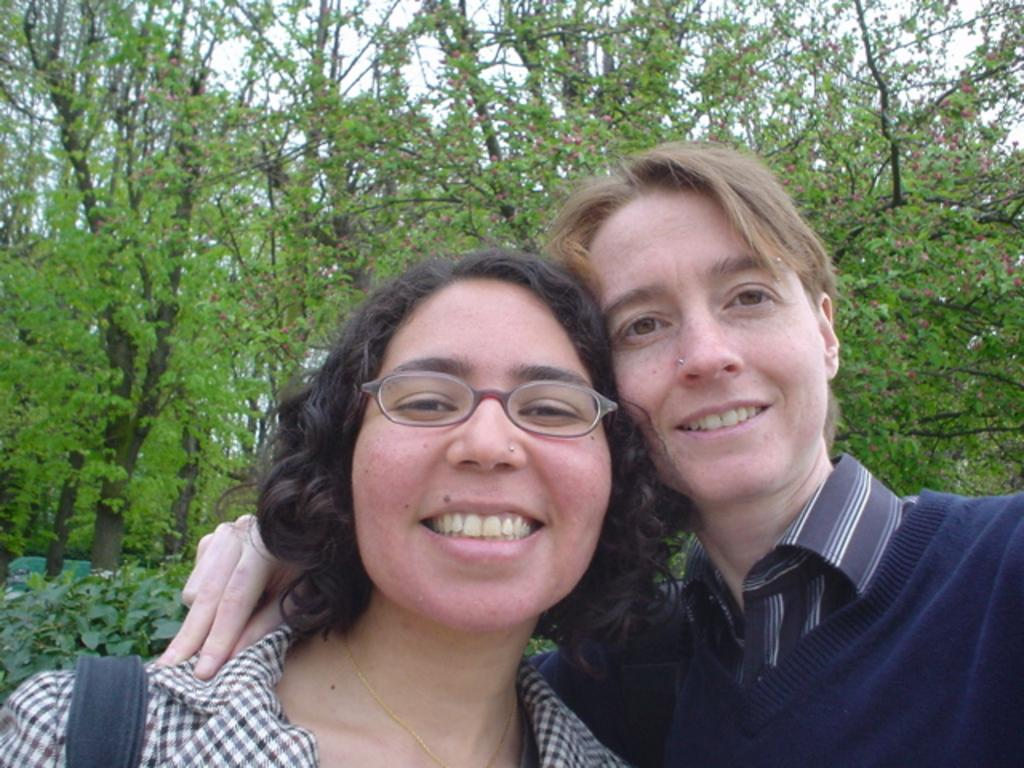How many people are in the image? There are two persons in the center of the image. What can be seen in the background of the image? There are trees and plants in the background of the image. What type of grape is being used to express love in the image? There is no grape or expression of love present in the image. 